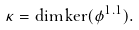Convert formula to latex. <formula><loc_0><loc_0><loc_500><loc_500>\kappa = \dim \ker ( \phi ^ { 1 . 1 } ) .</formula> 